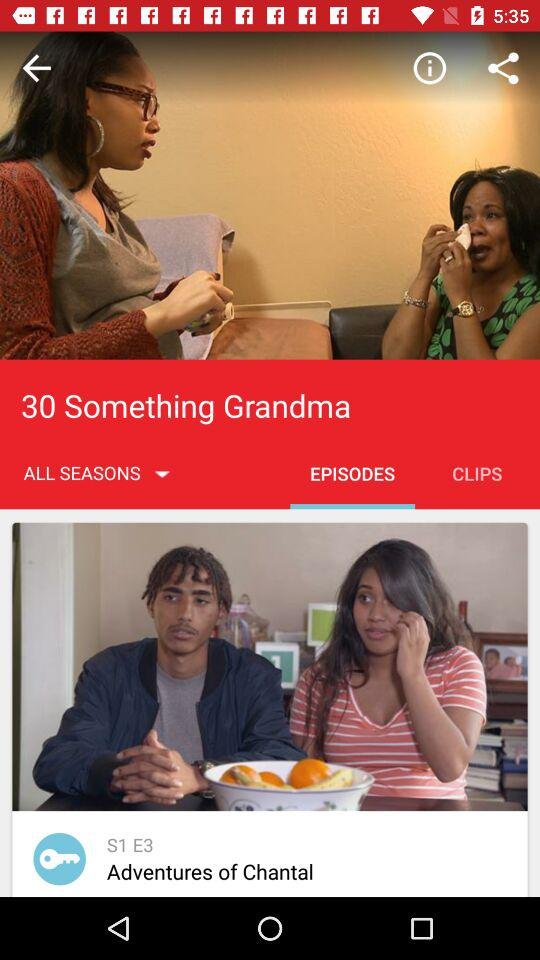How many seasons are there of this show?
Answer the question using a single word or phrase. 1 